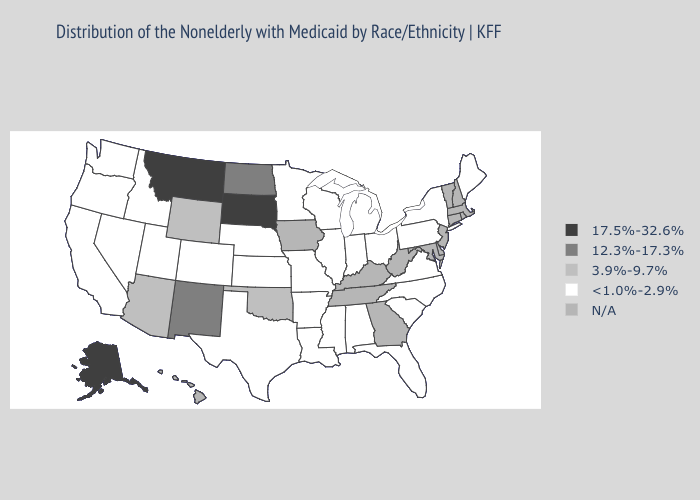Name the states that have a value in the range N/A?
Be succinct. Connecticut, Delaware, Georgia, Hawaii, Iowa, Kentucky, Maryland, Massachusetts, New Hampshire, New Jersey, Rhode Island, Tennessee, Vermont, West Virginia. Name the states that have a value in the range N/A?
Answer briefly. Connecticut, Delaware, Georgia, Hawaii, Iowa, Kentucky, Maryland, Massachusetts, New Hampshire, New Jersey, Rhode Island, Tennessee, Vermont, West Virginia. Does Idaho have the lowest value in the USA?
Be succinct. Yes. Which states hav the highest value in the South?
Be succinct. Oklahoma. Does Wisconsin have the lowest value in the MidWest?
Concise answer only. Yes. What is the highest value in the MidWest ?
Keep it brief. 17.5%-32.6%. What is the value of Oregon?
Keep it brief. <1.0%-2.9%. Name the states that have a value in the range <1.0%-2.9%?
Write a very short answer. Alabama, Arkansas, California, Colorado, Florida, Idaho, Illinois, Indiana, Kansas, Louisiana, Maine, Michigan, Minnesota, Mississippi, Missouri, Nebraska, Nevada, New York, North Carolina, Ohio, Oregon, Pennsylvania, South Carolina, Texas, Utah, Virginia, Washington, Wisconsin. What is the value of Oklahoma?
Quick response, please. 3.9%-9.7%. What is the value of New York?
Keep it brief. <1.0%-2.9%. Does Montana have the lowest value in the USA?
Write a very short answer. No. Which states have the lowest value in the West?
Be succinct. California, Colorado, Idaho, Nevada, Oregon, Utah, Washington. Name the states that have a value in the range <1.0%-2.9%?
Write a very short answer. Alabama, Arkansas, California, Colorado, Florida, Idaho, Illinois, Indiana, Kansas, Louisiana, Maine, Michigan, Minnesota, Mississippi, Missouri, Nebraska, Nevada, New York, North Carolina, Ohio, Oregon, Pennsylvania, South Carolina, Texas, Utah, Virginia, Washington, Wisconsin. Which states have the highest value in the USA?
Write a very short answer. Alaska, Montana, South Dakota. 